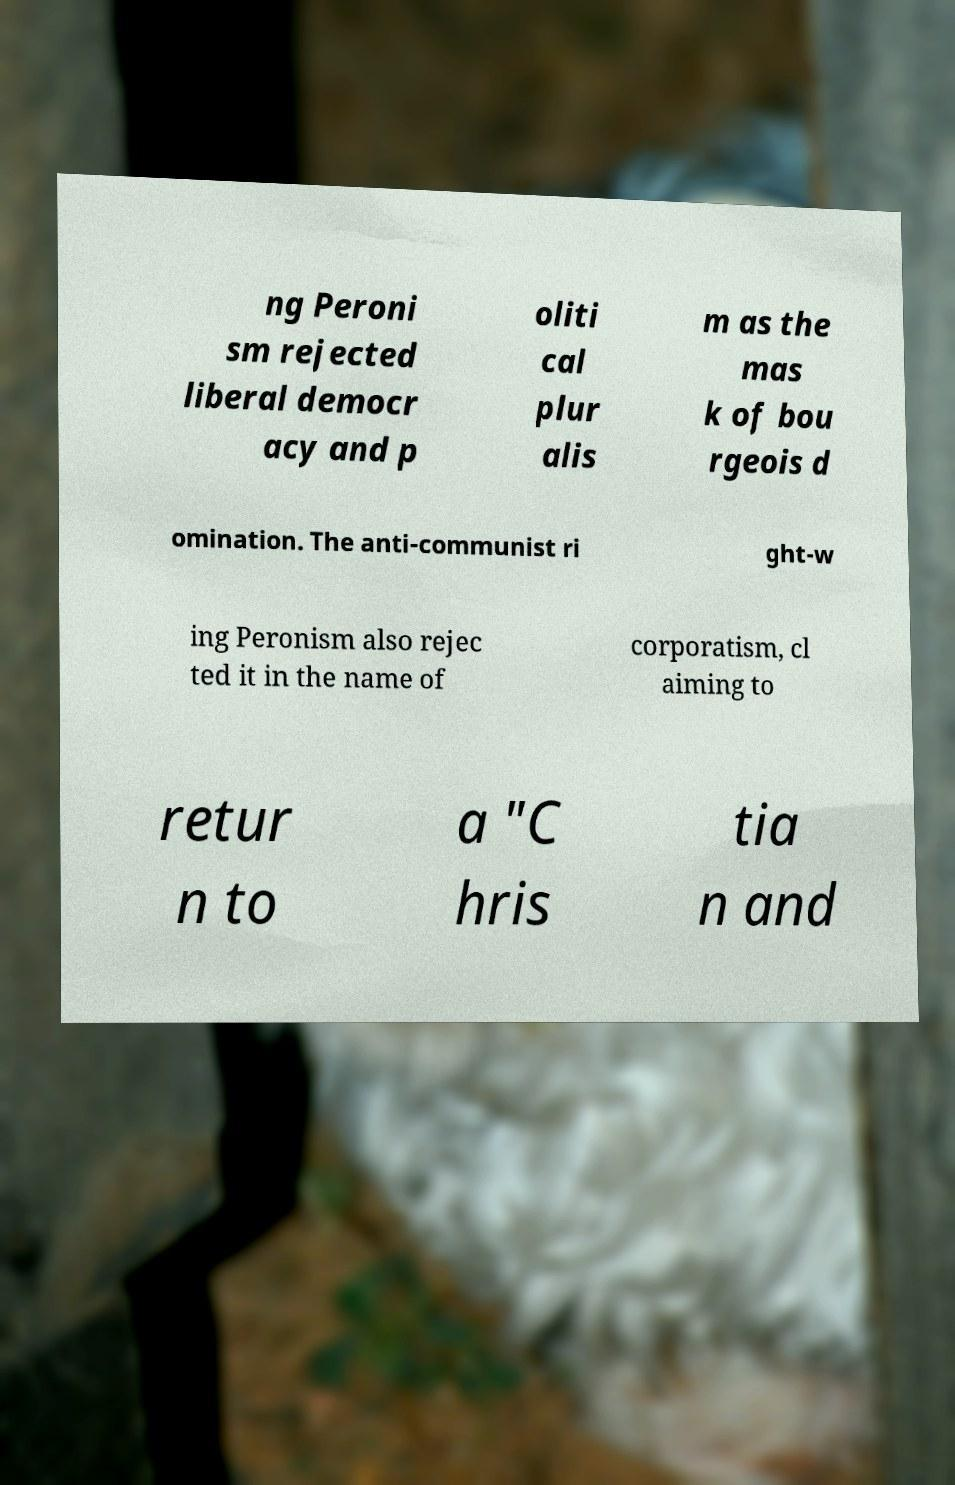I need the written content from this picture converted into text. Can you do that? ng Peroni sm rejected liberal democr acy and p oliti cal plur alis m as the mas k of bou rgeois d omination. The anti-communist ri ght-w ing Peronism also rejec ted it in the name of corporatism, cl aiming to retur n to a "C hris tia n and 